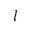<formula> <loc_0><loc_0><loc_500><loc_500>l</formula> 